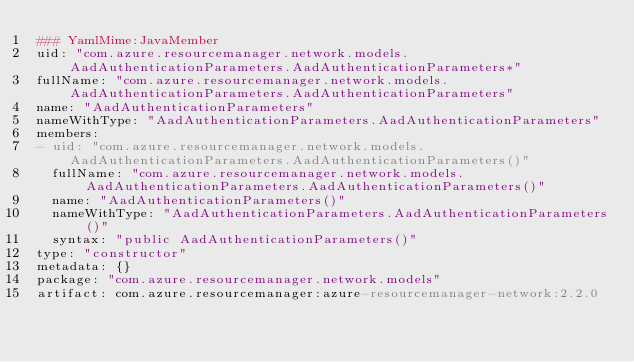<code> <loc_0><loc_0><loc_500><loc_500><_YAML_>### YamlMime:JavaMember
uid: "com.azure.resourcemanager.network.models.AadAuthenticationParameters.AadAuthenticationParameters*"
fullName: "com.azure.resourcemanager.network.models.AadAuthenticationParameters.AadAuthenticationParameters"
name: "AadAuthenticationParameters"
nameWithType: "AadAuthenticationParameters.AadAuthenticationParameters"
members:
- uid: "com.azure.resourcemanager.network.models.AadAuthenticationParameters.AadAuthenticationParameters()"
  fullName: "com.azure.resourcemanager.network.models.AadAuthenticationParameters.AadAuthenticationParameters()"
  name: "AadAuthenticationParameters()"
  nameWithType: "AadAuthenticationParameters.AadAuthenticationParameters()"
  syntax: "public AadAuthenticationParameters()"
type: "constructor"
metadata: {}
package: "com.azure.resourcemanager.network.models"
artifact: com.azure.resourcemanager:azure-resourcemanager-network:2.2.0
</code> 